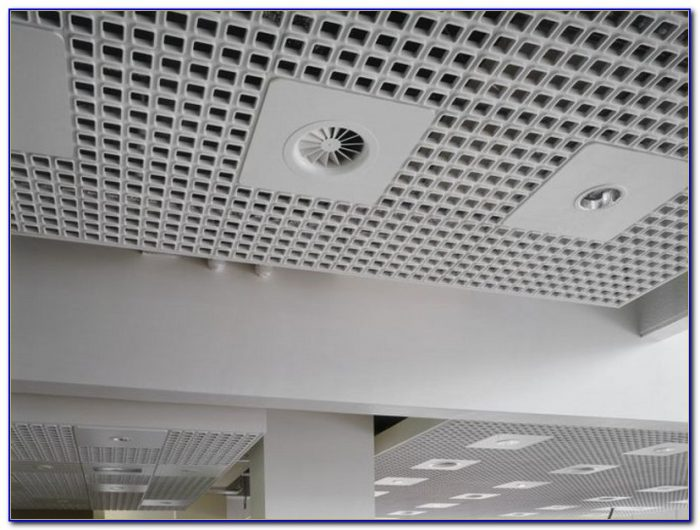Considering the design and function of the elements observed in the ceiling, what might be the purpose of the circular perforations in the ceiling tiles, and how do they contribute to the overall design and functionality of the space? The circular perforations in the ceiling tiles are ingeniously designed to fulfill several crucial functions simultaneously. Acoustically, these perforations contribute significantly to sound absorption, effectively minimizing noise distractions by disrupting sound waves, thus fostering tranquil and focused environments ideal in settings like offices or libraries. Functionally, they support ventilation, improving air quality by enhancing the flow and distribution of air, increasing overall comfort. Aesthetically, the circular motifs provide a sleek, contemporary look, integrating essential services seamlessly into the spatial design to maintain a clean and uncluttered aesthetic. Therefore, they serve a key role in both the practical utility and visual harmony of the space. 